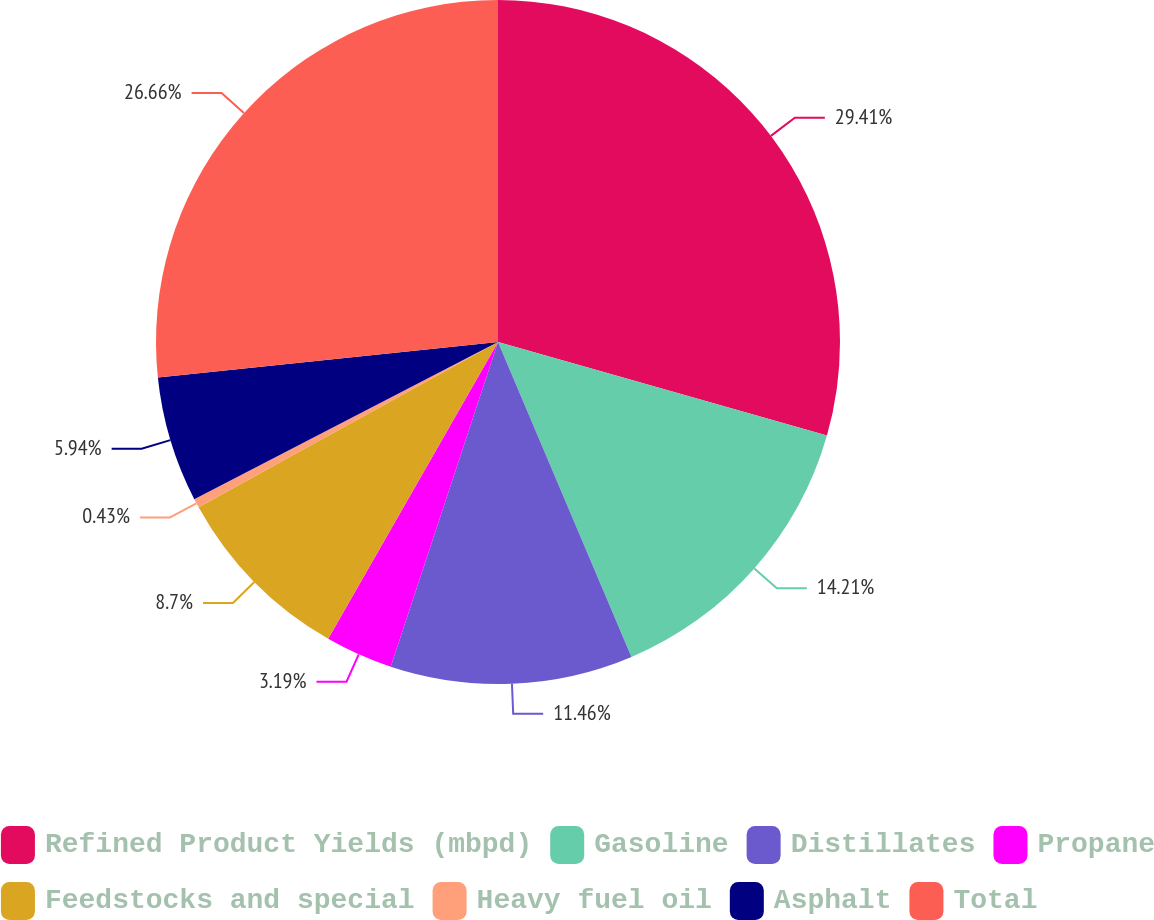Convert chart. <chart><loc_0><loc_0><loc_500><loc_500><pie_chart><fcel>Refined Product Yields (mbpd)<fcel>Gasoline<fcel>Distillates<fcel>Propane<fcel>Feedstocks and special<fcel>Heavy fuel oil<fcel>Asphalt<fcel>Total<nl><fcel>29.41%<fcel>14.21%<fcel>11.46%<fcel>3.19%<fcel>8.7%<fcel>0.43%<fcel>5.94%<fcel>26.66%<nl></chart> 